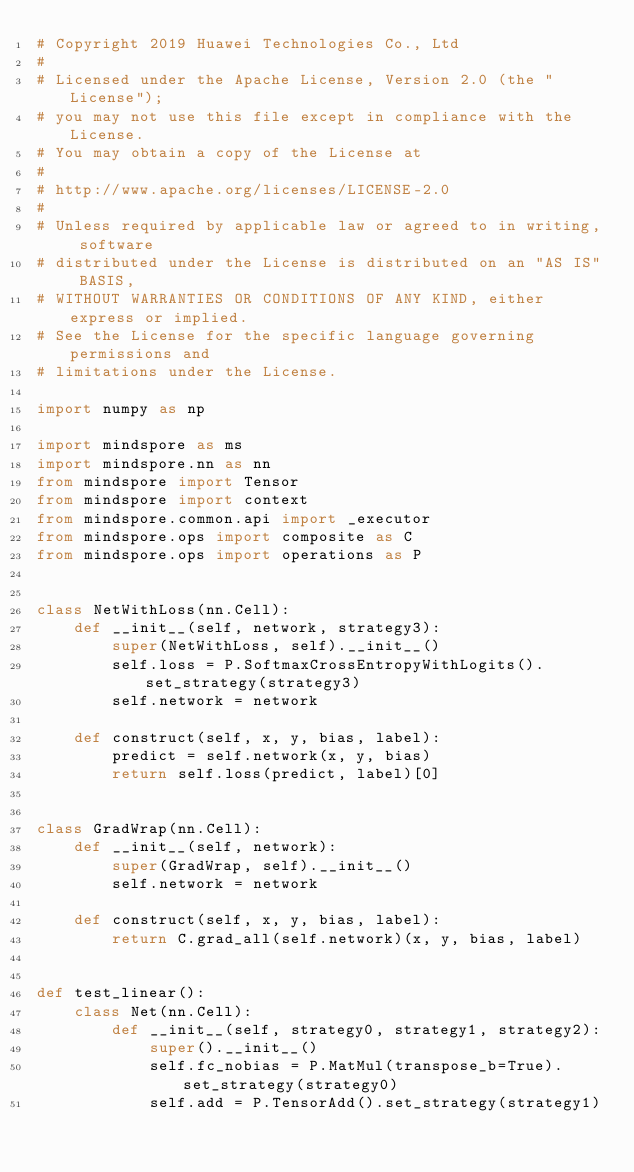<code> <loc_0><loc_0><loc_500><loc_500><_Python_># Copyright 2019 Huawei Technologies Co., Ltd
#
# Licensed under the Apache License, Version 2.0 (the "License");
# you may not use this file except in compliance with the License.
# You may obtain a copy of the License at
#
# http://www.apache.org/licenses/LICENSE-2.0
#
# Unless required by applicable law or agreed to in writing, software
# distributed under the License is distributed on an "AS IS" BASIS,
# WITHOUT WARRANTIES OR CONDITIONS OF ANY KIND, either express or implied.
# See the License for the specific language governing permissions and
# limitations under the License.

import numpy as np

import mindspore as ms
import mindspore.nn as nn
from mindspore import Tensor
from mindspore import context
from mindspore.common.api import _executor
from mindspore.ops import composite as C
from mindspore.ops import operations as P


class NetWithLoss(nn.Cell):
    def __init__(self, network, strategy3):
        super(NetWithLoss, self).__init__()
        self.loss = P.SoftmaxCrossEntropyWithLogits().set_strategy(strategy3)
        self.network = network

    def construct(self, x, y, bias, label):
        predict = self.network(x, y, bias)
        return self.loss(predict, label)[0]


class GradWrap(nn.Cell):
    def __init__(self, network):
        super(GradWrap, self).__init__()
        self.network = network

    def construct(self, x, y, bias, label):
        return C.grad_all(self.network)(x, y, bias, label)


def test_linear():
    class Net(nn.Cell):
        def __init__(self, strategy0, strategy1, strategy2):
            super().__init__()
            self.fc_nobias = P.MatMul(transpose_b=True).set_strategy(strategy0)
            self.add = P.TensorAdd().set_strategy(strategy1)</code> 